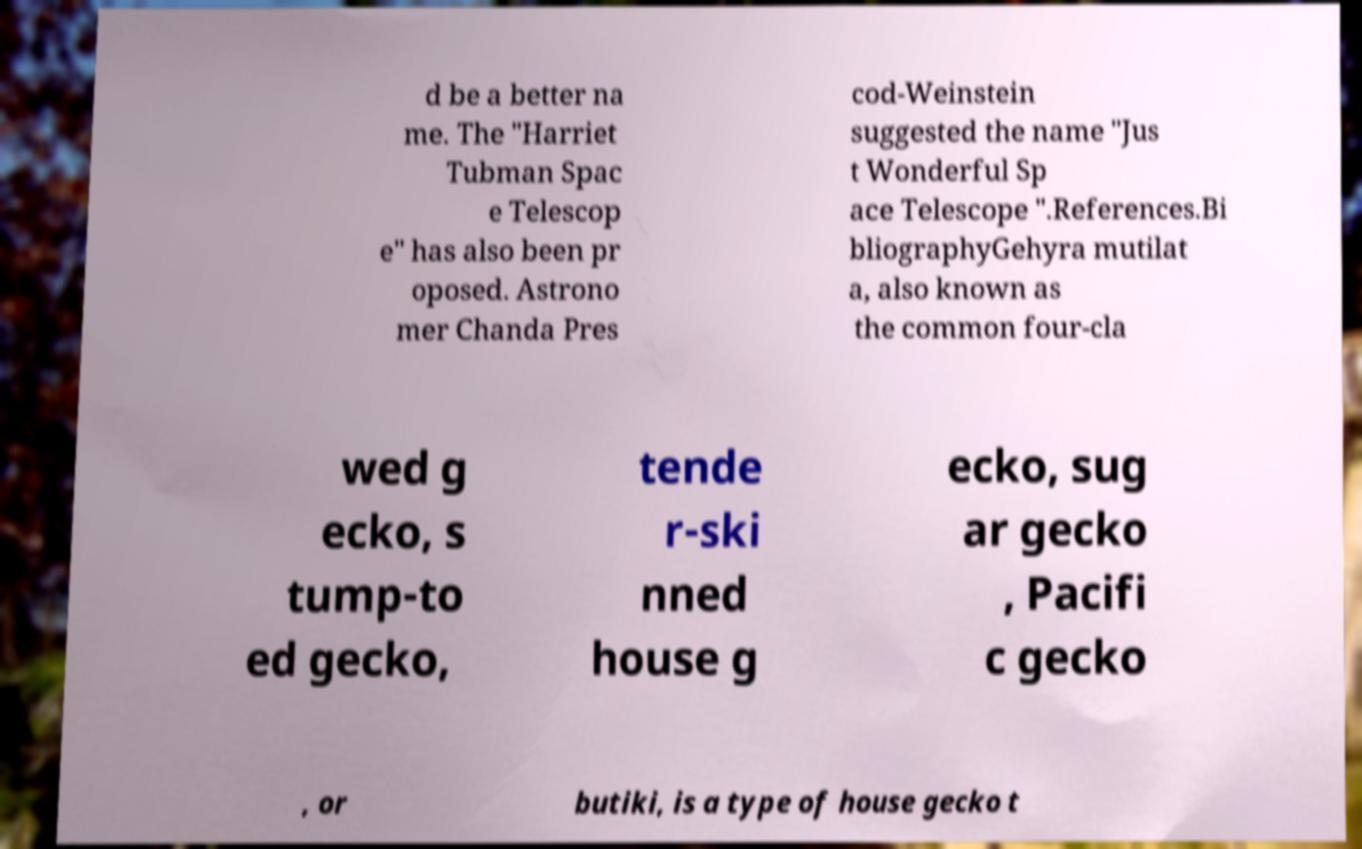What messages or text are displayed in this image? I need them in a readable, typed format. d be a better na me. The "Harriet Tubman Spac e Telescop e" has also been pr oposed. Astrono mer Chanda Pres cod-Weinstein suggested the name "Jus t Wonderful Sp ace Telescope ".References.Bi bliographyGehyra mutilat a, also known as the common four-cla wed g ecko, s tump-to ed gecko, tende r-ski nned house g ecko, sug ar gecko , Pacifi c gecko , or butiki, is a type of house gecko t 